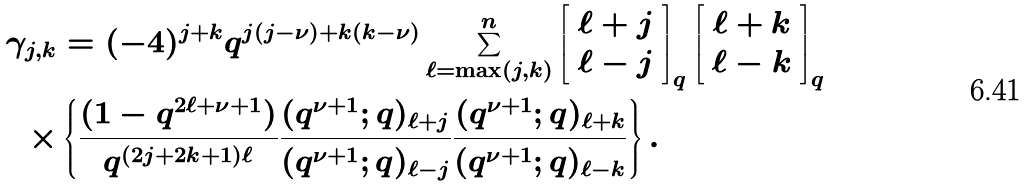Convert formula to latex. <formula><loc_0><loc_0><loc_500><loc_500>\gamma _ { j , k } & = ( - 4 ) ^ { j + k } q ^ { j ( j - \nu ) + k ( k - \nu ) } \sum _ { \ell = \max ( j , k ) } ^ { n } \left [ \begin{array} { c } \ell + j \\ \ell - j \end{array} \right ] _ { q } \left [ \begin{array} { c } \ell + k \\ \ell - k \end{array} \right ] _ { q } \\ \times & \left \{ \frac { ( 1 - q ^ { 2 \ell + \nu + 1 } ) } { q ^ { ( 2 j + 2 k + 1 ) \ell } } \frac { ( q ^ { \nu + 1 } ; q ) _ { \ell + j } } { ( q ^ { \nu + 1 } ; q ) _ { \ell - j } } \frac { ( q ^ { \nu + 1 } ; q ) _ { \ell + k } } { ( q ^ { \nu + 1 } ; q ) _ { \ell - k } } \right \} .</formula> 